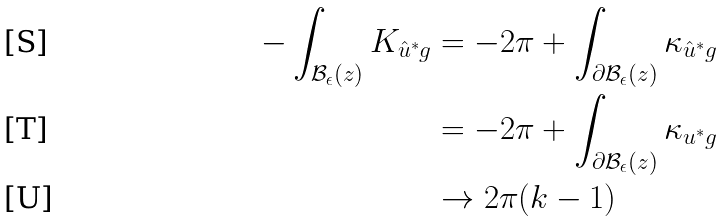<formula> <loc_0><loc_0><loc_500><loc_500>- \int _ { \mathcal { B } _ { \epsilon } ( z ) } K _ { \hat { u } ^ { * } g } & = - 2 \pi + \int _ { \partial \mathcal { B } _ { \epsilon } ( z ) } \kappa _ { \hat { u } ^ { * } g } \\ & = - 2 \pi + \int _ { \partial \mathcal { B } _ { \epsilon } ( z ) } \kappa _ { u ^ { * } g } \\ & \to 2 \pi ( k - 1 )</formula> 